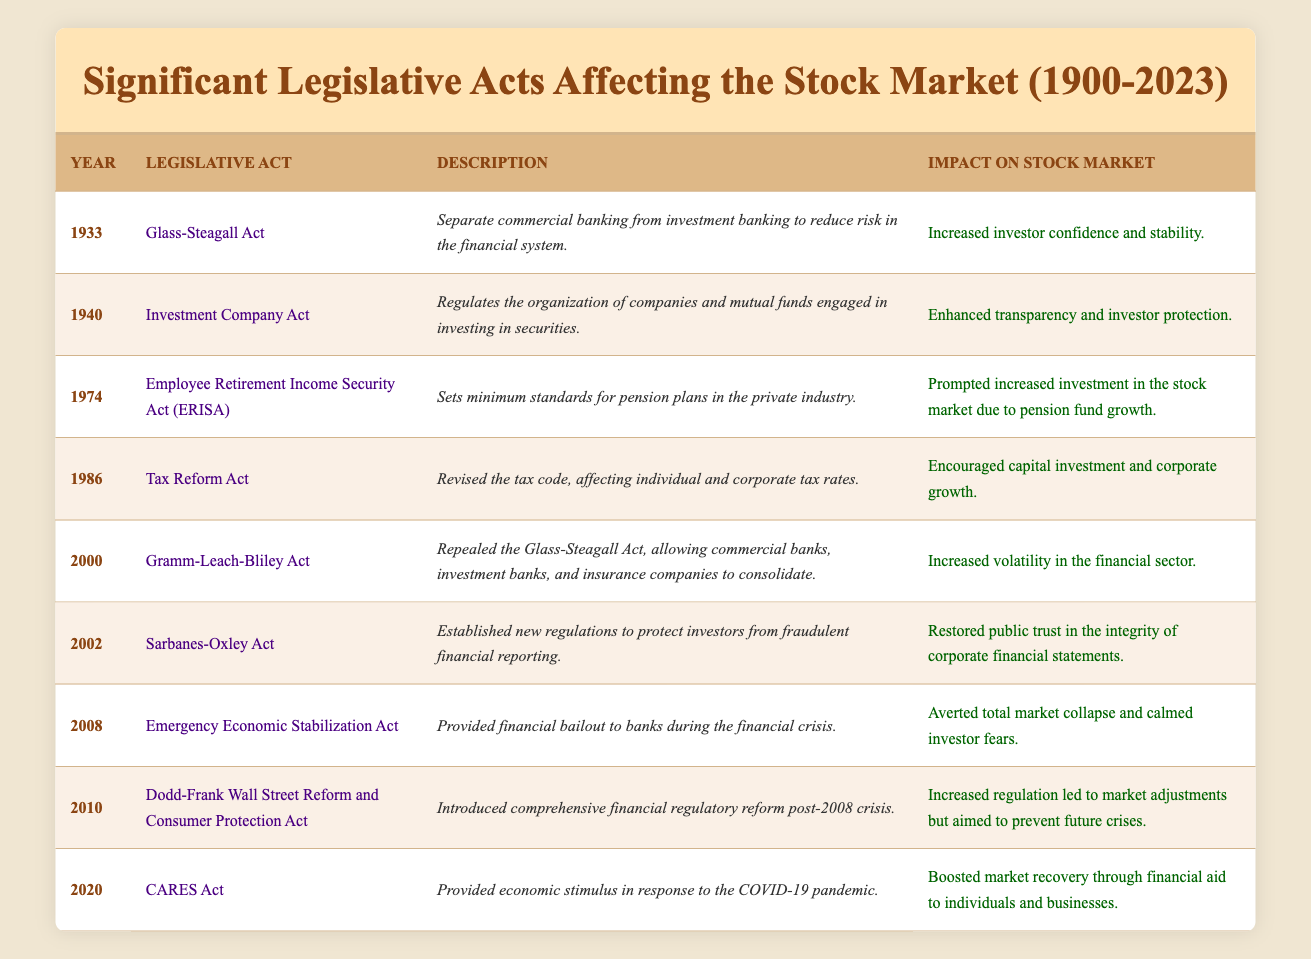What is the legislative act passed in 1974? The year 1974 has one legislative act listed, which is the Employee Retirement Income Security Act (ERISA). This information can be directly retrieved from the table.
Answer: Employee Retirement Income Security Act (ERISA) Which act aimed to separate commercial and investment banking? The Glass-Steagall Act, passed in 1933, is the act that aimed to separate commercial banking from investment banking. This is explicitly mentioned in the table.
Answer: Glass-Steagall Act How many legislative acts were passed in the 2000s? There are four acts listed in the table that were passed in the 2000s: the Gramm-Leach-Bliley Act in 2000, the Sarbanes-Oxley Act in 2002, the Emergency Economic Stabilization Act in 2008, and the Dodd-Frank Act in 2010. Counting these, we find four acts.
Answer: 4 Was the CARES Act aimed at aiding individuals and businesses during the COVID-19 pandemic? According to the table, the CARES Act, passed in 2020, provided economic stimulus in response to the COVID-19 pandemic, which included financial aid to individuals and businesses. Thus, the statement is true.
Answer: Yes Which act had an impact characterized as "increased volatility in the financial sector"? The legislative act that had this specific impact is the Gramm-Leach-Bliley Act, passed in 2000. This information can be confirmed by reviewing the impact descriptions in the table.
Answer: Gramm-Leach-Bliley Act What was the average year of the acts listed from 2000 to 2023? The acts listed from 2000 to 2023 are from the years 2000, 2002, 2008, and 2010, totaling four acts (2000 + 2002 + 2008 + 2010 = 8020). The average is 8020/4 = 2005.
Answer: 2005 Which act was passed to address fraudulent financial reporting? The Sarbanes-Oxley Act, enacted in 2002, was established to protect investors from fraudulent financial reporting, as stated in the table's description for this act.
Answer: Sarbanes-Oxley Act Did any act aim to enhance transparency and investor protection? Yes, the Investment Company Act of 1940 is noted in the table for enhancing transparency and investor protection. Therefore, this fact is true.
Answer: Yes What was the primary aim of the Emergency Economic Stabilization Act? The Emergency Economic Stabilization Act, passed in 2008, aimed to provide financial bailouts to banks during the financial crisis as described in the table.
Answer: Averted total market collapse and calmed investor fears 